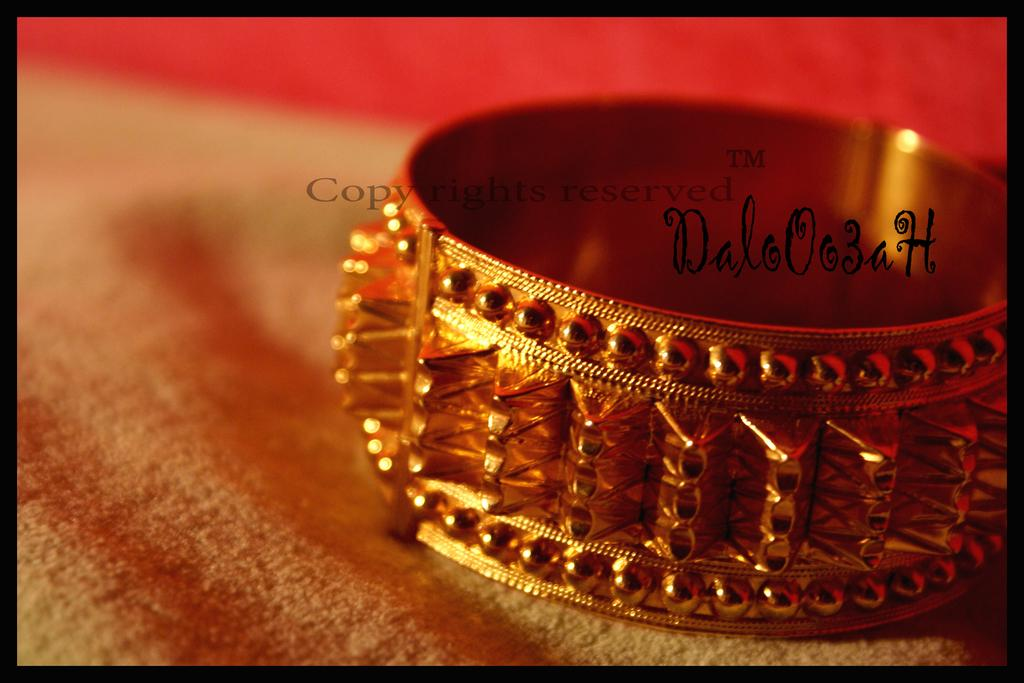What is the main object in the picture? There is a bangle in the picture. Where is the bangle located? The bangle is placed on a surface. Can you describe any additional features of the image? There is a watermark on the image. What is the slope of the bangle in the image? The bangle is not depicted as having a slope in the image; it is a flat, circular object. 